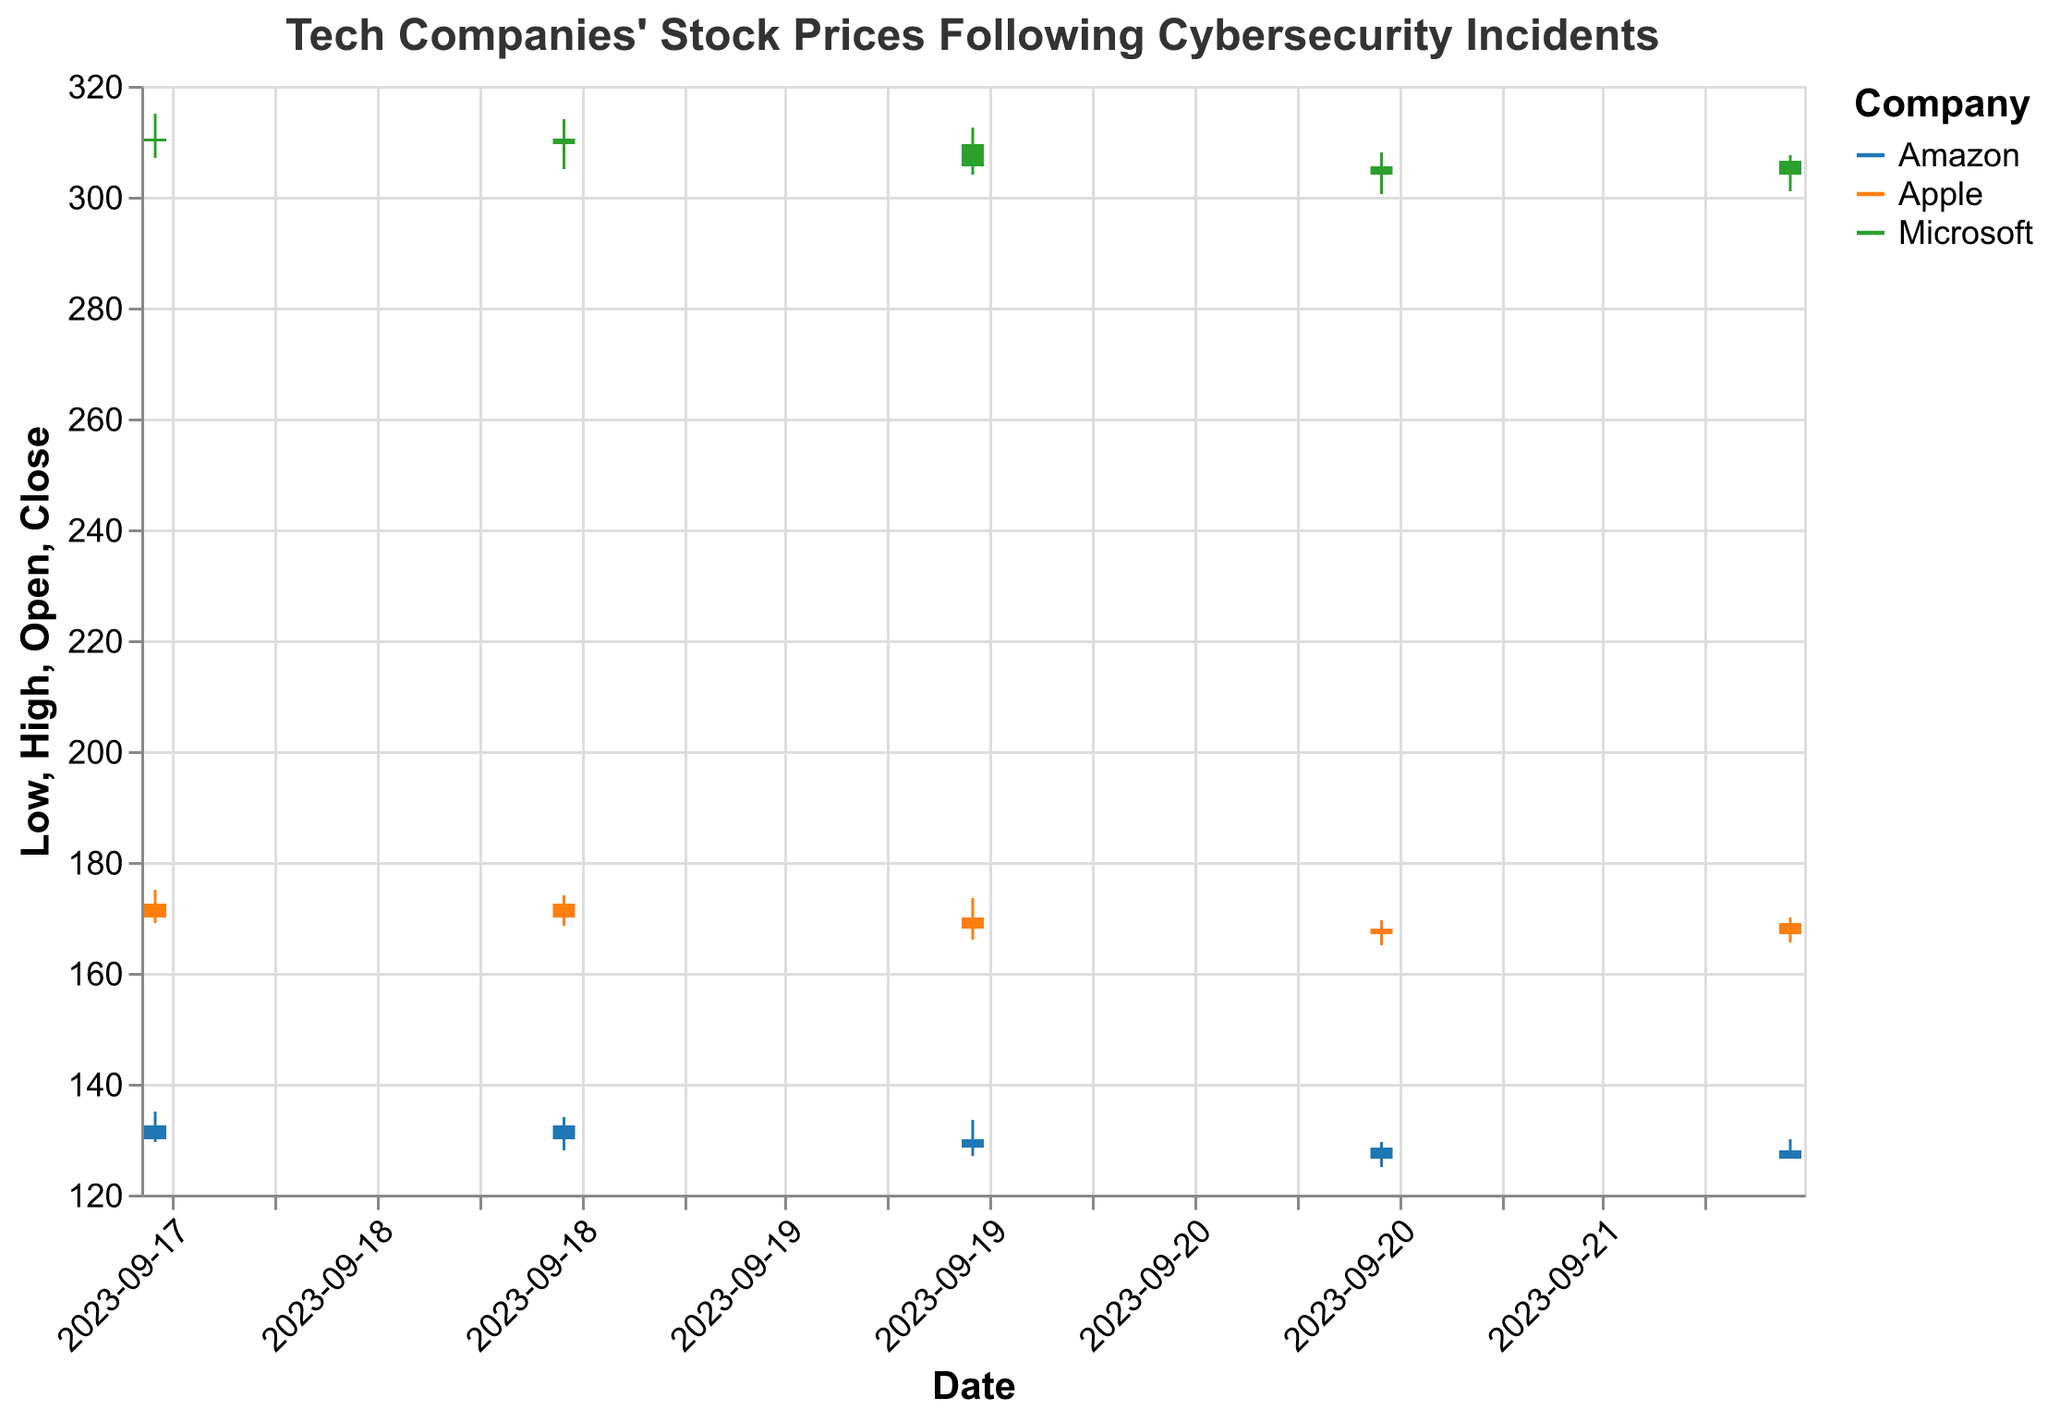What is the title of the figure? The title is displayed at the top of the figure, describing the overall content. The text is "Tech Companies' Stock Prices Following Cybersecurity Incidents".
Answer: Tech Companies' Stock Prices Following Cybersecurity Incidents How many companies are represented in the figure? The companies are distinguished by different colors in the figure, and by examining the legend, we see three distinct companies: Apple, Microsoft, and Amazon.
Answer: Three On which date did Apple have the highest closing price? By examining each candlestick for Apple, we find the highest closing price on 2023-09-18, where the closing price is 172.50.
Answer: 2023-09-18 What was the closing price for Amazon on the last date in the data? The last date in the data is 2023-09-22 for Amazon, and the corresponding closing price for that date is 128.00.
Answer: 128.00 Which company had the highest volume of trades on 2023-09-20? By comparing the trade volumes for all companies on 2023-09-20, Amazon has the highest volume with 104,000,000 trades.
Answer: Amazon How did Microsoft’s stock price move from the opening on 2023-09-21 to the closing on 2023-09-22? Looking at Microsoft’s data, on 2023-09-21, it opened at 305.50 and closed at 304.00. On 2023-09-22, it opened at 304.00 and closed at 306.50. The price first decreased and then increased.
Answer: Decrease then increase Which company had the largest range between its high and low on 2023-09-18? The range is calculated by subtracting the low from the high for each company on 2023-09-18. Apple: 6 (175-169), Microsoft: 8 (315-307), Amazon: 5.5 (135-129.5). Microsoft had the largest range.
Answer: Microsoft What was the general trend of Apple's stock prices over this week? By observing the candlesticks for Apple from 2023-09-18 to 2023-09-22, we see that the prices started high and then trended downwards overall.
Answer: Downwards Compare the trading volumes of Amazon and Microsoft on 2023-09-19. Which had a higher volume? Amazon's volume: 99,000,000; Microsoft’s volume: 85,000,000. Amazon had a higher volume on that date.
Answer: Amazon Between 2023-09-18 and 2023-09-22, did Microsoft ever close on a price higher than it opened on that day? Examining the close and open prices for Microsoft, it always closed at or below its opening price within this range.
Answer: No 